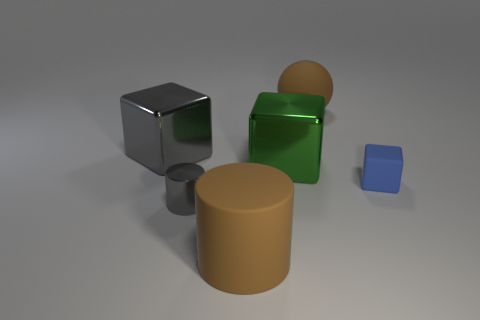Subtract all green blocks. Subtract all green cylinders. How many blocks are left? 2 Add 1 blue matte objects. How many objects exist? 7 Subtract all spheres. How many objects are left? 5 Add 1 small cylinders. How many small cylinders are left? 2 Add 5 big brown metal objects. How many big brown metal objects exist? 5 Subtract 1 green cubes. How many objects are left? 5 Subtract all tiny gray metal cylinders. Subtract all metallic cylinders. How many objects are left? 4 